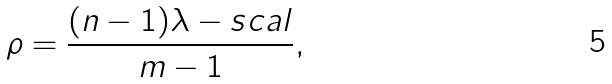Convert formula to latex. <formula><loc_0><loc_0><loc_500><loc_500>\rho = \frac { ( n - 1 ) \lambda - s c a l } { m - 1 } ,</formula> 